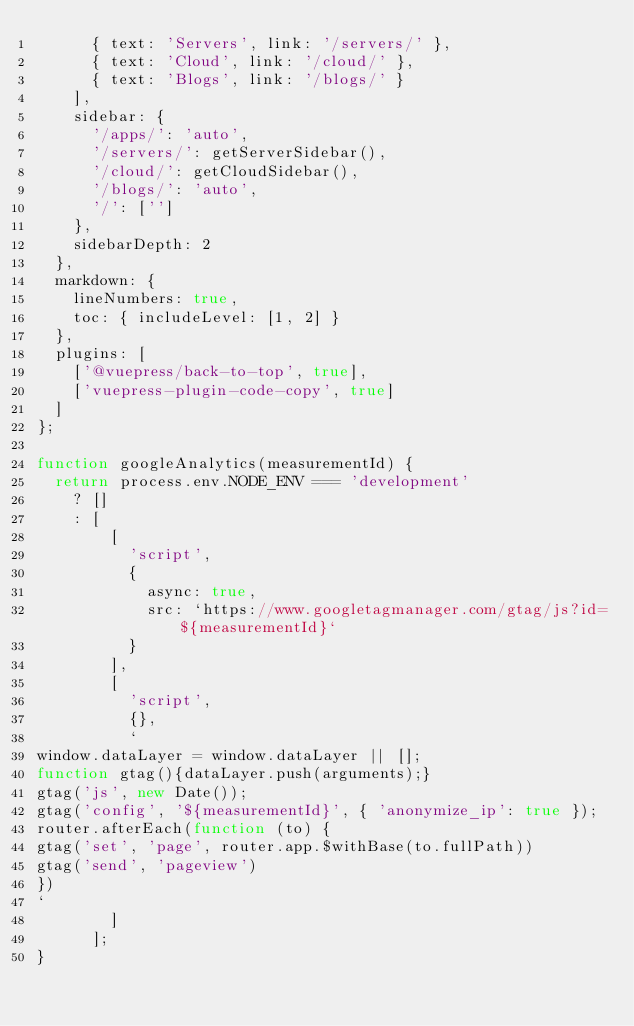Convert code to text. <code><loc_0><loc_0><loc_500><loc_500><_JavaScript_>      { text: 'Servers', link: '/servers/' },
      { text: 'Cloud', link: '/cloud/' },
      { text: 'Blogs', link: '/blogs/' }
    ],
    sidebar: {
      '/apps/': 'auto',
      '/servers/': getServerSidebar(),
      '/cloud/': getCloudSidebar(),
      '/blogs/': 'auto',
      '/': ['']
    },
    sidebarDepth: 2
  },
  markdown: {
    lineNumbers: true,
    toc: { includeLevel: [1, 2] }
  },
  plugins: [
    ['@vuepress/back-to-top', true],
    ['vuepress-plugin-code-copy', true]
  ]
};

function googleAnalytics(measurementId) {
  return process.env.NODE_ENV === 'development'
    ? []
    : [
        [
          'script',
          {
            async: true,
            src: `https://www.googletagmanager.com/gtag/js?id=${measurementId}`
          }
        ],
        [
          'script',
          {},
          `
window.dataLayer = window.dataLayer || [];
function gtag(){dataLayer.push(arguments);}
gtag('js', new Date());
gtag('config', '${measurementId}', { 'anonymize_ip': true });
router.afterEach(function (to) {
gtag('set', 'page', router.app.$withBase(to.fullPath))
gtag('send', 'pageview')
})
`
        ]
      ];
}
</code> 